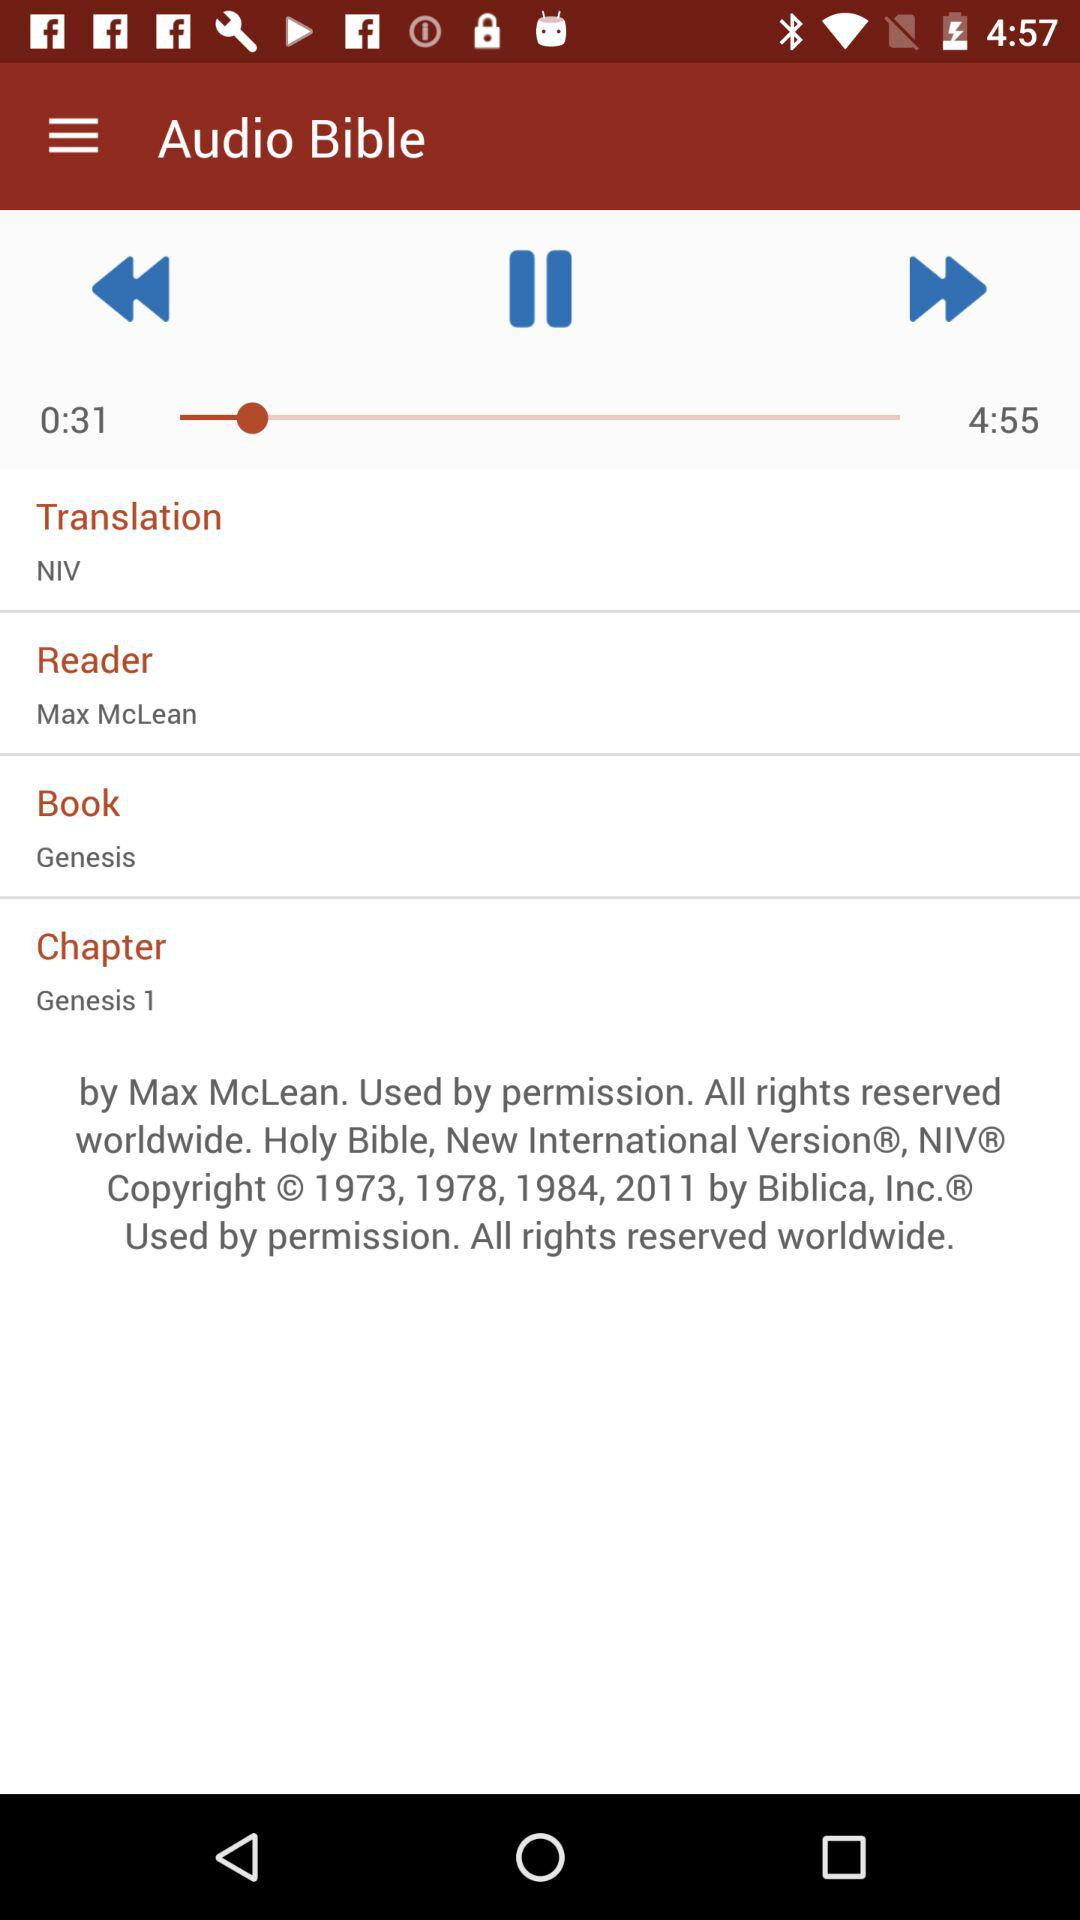What is the name of the chapter? The name of the chapter is "Genesis 1". 